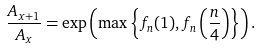<formula> <loc_0><loc_0><loc_500><loc_500>\frac { A _ { x + 1 } } { A _ { x } } = \exp \left ( \max \left \{ f _ { n } ( 1 ) , f _ { n } \left ( \frac { n } { 4 } \right ) \right \} \right ) .</formula> 